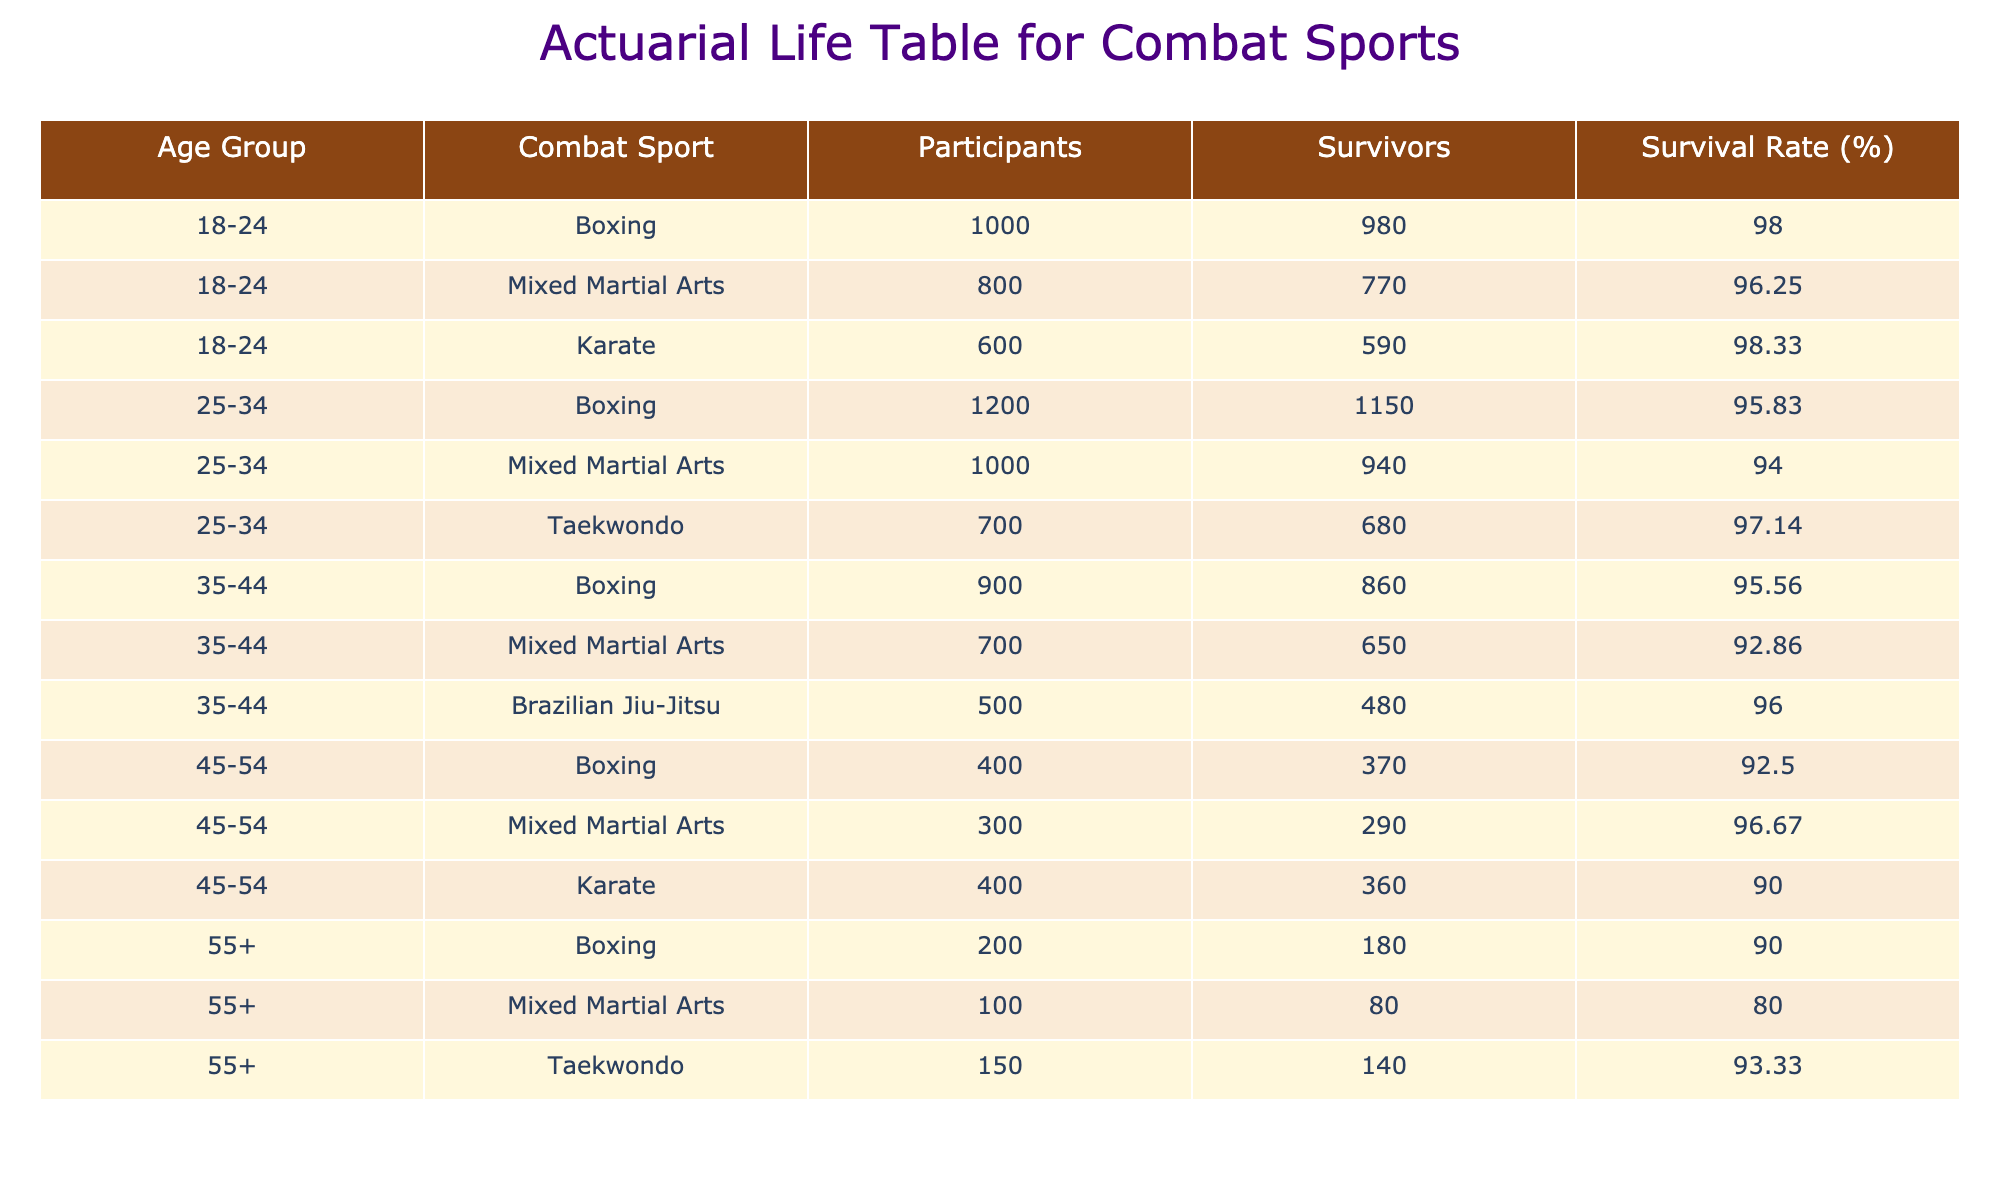What is the survival rate for participants aged 18-24 in Mixed Martial Arts? According to the table, for the age group 18-24 in Mixed Martial Arts, there are 800 participants and 770 survivors. The survival rate can be calculated as (770/800) * 100 = 96.25%.
Answer: 96.25% Which combat sport has the highest survival rate for participants aged 25-34? To find the highest survival rate for the age group 25-34, we compare the survival rates: Boxing (95.83%), Mixed Martial Arts (94.0%), Taekwondo (97.14%). The highest is Taekwondo at 97.14%.
Answer: Taekwondo Is the survival rate among participants aged 45-54 in Karate higher than that in Boxing? The survival rate for Karate (90.0%) is lower than Boxing (92.5%) for the age group 45-54, making this statement false.
Answer: No What is the average survival rate across all combat sports for participants aged 35-44? To calculate the average survival rate for the age group 35-44: (95.56% + 92.86% + 96.0%) / 3 = 94.47%. Thus, the average survival rate is approximately 94.47%.
Answer: 94.47% Which age group has the lowest survival rate in Mixed Martial Arts? In Mixed Martial Arts, the survival rates per age group are: 96.25% (18-24), 94.0% (25-34), and 92.86% (35-44), 96.67% (45-54), 80.0% (55+). The lowest is 80.0% for age group 55+.
Answer: 55+ What is the total number of survivors in Boxing across all age groups? The total survivors in Boxing across all age groups can be calculated by adding them up: 980 (18-24) + 1150 (25-34) + 860 (35-44) + 370 (45-54) + 180 (55+) = 3540 survivors in total.
Answer: 3540 Are the survival rates for age groups 45-54 for Mixed Martial Arts and Karate equal? The survival rate for Mixed Martial Arts (96.67%) is higher than that for Karate (90.0%), indicating that they are not equal.
Answer: No What is the difference in survival rates between the age group 18-24 and 55+ in Taekwondo? Taekwondo only has data for the age group 55+ (93.33%). Since there's no data for 18-24 in Taekwondo in the context given, the comparison is not possible.
Answer: N/A 